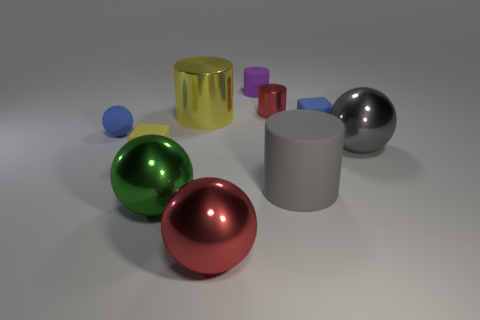Subtract all purple cylinders. How many cylinders are left? 3 Subtract all purple cylinders. How many cylinders are left? 3 Subtract 1 balls. How many balls are left? 3 Subtract all brown balls. Subtract all cyan cylinders. How many balls are left? 4 Subtract all large purple shiny objects. Subtract all big matte things. How many objects are left? 9 Add 3 purple matte cylinders. How many purple matte cylinders are left? 4 Add 7 rubber blocks. How many rubber blocks exist? 9 Subtract 0 brown blocks. How many objects are left? 10 Subtract all cubes. How many objects are left? 8 